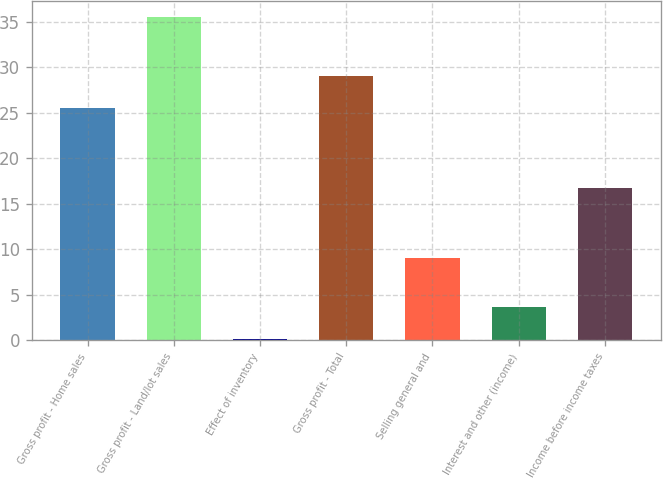Convert chart to OTSL. <chart><loc_0><loc_0><loc_500><loc_500><bar_chart><fcel>Gross profit - Home sales<fcel>Gross profit - Land/lot sales<fcel>Effect of inventory<fcel>Gross profit - Total<fcel>Selling general and<fcel>Interest and other (income)<fcel>Income before income taxes<nl><fcel>25.5<fcel>35.5<fcel>0.1<fcel>29.04<fcel>9<fcel>3.64<fcel>16.7<nl></chart> 